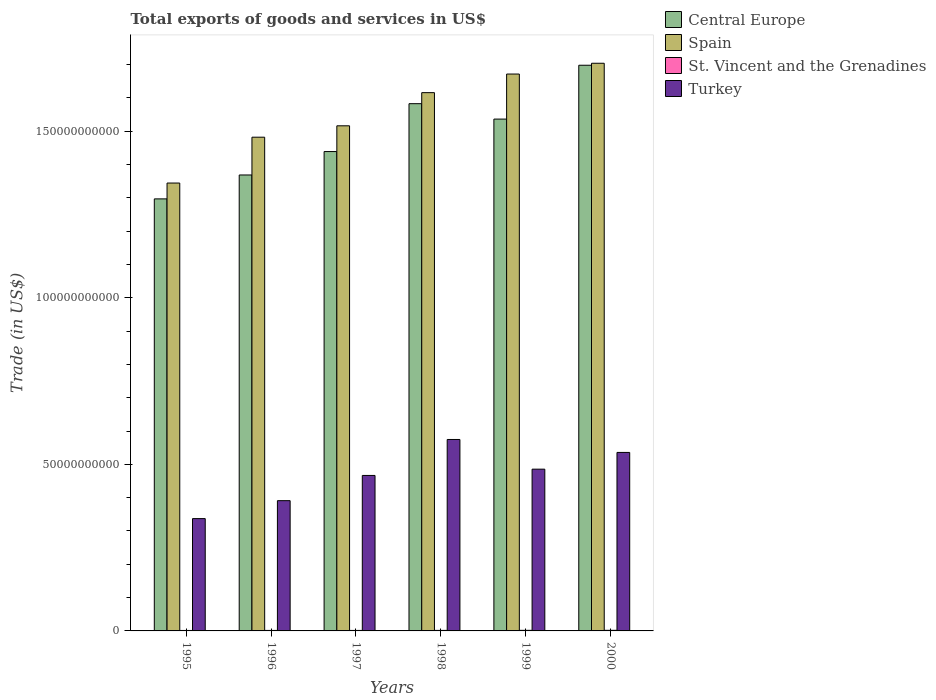How many different coloured bars are there?
Make the answer very short. 4. How many groups of bars are there?
Ensure brevity in your answer.  6. How many bars are there on the 4th tick from the right?
Keep it short and to the point. 4. What is the total exports of goods and services in Central Europe in 1998?
Your response must be concise. 1.58e+11. Across all years, what is the maximum total exports of goods and services in St. Vincent and the Grenadines?
Keep it short and to the point. 1.79e+08. Across all years, what is the minimum total exports of goods and services in St. Vincent and the Grenadines?
Your answer should be compact. 1.36e+08. What is the total total exports of goods and services in St. Vincent and the Grenadines in the graph?
Give a very brief answer. 9.48e+08. What is the difference between the total exports of goods and services in Spain in 1997 and that in 1999?
Make the answer very short. -1.55e+1. What is the difference between the total exports of goods and services in Spain in 1999 and the total exports of goods and services in Central Europe in 1996?
Your answer should be very brief. 3.03e+1. What is the average total exports of goods and services in Central Europe per year?
Make the answer very short. 1.49e+11. In the year 2000, what is the difference between the total exports of goods and services in Spain and total exports of goods and services in Turkey?
Your answer should be very brief. 1.17e+11. In how many years, is the total exports of goods and services in Turkey greater than 20000000000 US$?
Give a very brief answer. 6. What is the ratio of the total exports of goods and services in Spain in 1995 to that in 1998?
Your answer should be compact. 0.83. Is the total exports of goods and services in Central Europe in 1999 less than that in 2000?
Make the answer very short. Yes. What is the difference between the highest and the second highest total exports of goods and services in St. Vincent and the Grenadines?
Keep it short and to the point. 2.23e+06. What is the difference between the highest and the lowest total exports of goods and services in St. Vincent and the Grenadines?
Keep it short and to the point. 4.31e+07. In how many years, is the total exports of goods and services in St. Vincent and the Grenadines greater than the average total exports of goods and services in St. Vincent and the Grenadines taken over all years?
Offer a very short reply. 2. Is the sum of the total exports of goods and services in Spain in 1999 and 2000 greater than the maximum total exports of goods and services in Central Europe across all years?
Make the answer very short. Yes. Is it the case that in every year, the sum of the total exports of goods and services in Turkey and total exports of goods and services in Central Europe is greater than the sum of total exports of goods and services in Spain and total exports of goods and services in St. Vincent and the Grenadines?
Offer a very short reply. Yes. What does the 2nd bar from the left in 1999 represents?
Your response must be concise. Spain. Is it the case that in every year, the sum of the total exports of goods and services in St. Vincent and the Grenadines and total exports of goods and services in Spain is greater than the total exports of goods and services in Central Europe?
Keep it short and to the point. Yes. How many bars are there?
Provide a short and direct response. 24. Are all the bars in the graph horizontal?
Your answer should be compact. No. How many years are there in the graph?
Give a very brief answer. 6. Are the values on the major ticks of Y-axis written in scientific E-notation?
Your answer should be compact. No. How many legend labels are there?
Your response must be concise. 4. How are the legend labels stacked?
Your answer should be compact. Vertical. What is the title of the graph?
Your response must be concise. Total exports of goods and services in US$. What is the label or title of the X-axis?
Your response must be concise. Years. What is the label or title of the Y-axis?
Offer a very short reply. Trade (in US$). What is the Trade (in US$) in Central Europe in 1995?
Provide a short and direct response. 1.30e+11. What is the Trade (in US$) of Spain in 1995?
Provide a short and direct response. 1.34e+11. What is the Trade (in US$) in St. Vincent and the Grenadines in 1995?
Provide a short and direct response. 1.36e+08. What is the Trade (in US$) in Turkey in 1995?
Provide a short and direct response. 3.37e+1. What is the Trade (in US$) of Central Europe in 1996?
Your answer should be compact. 1.37e+11. What is the Trade (in US$) of Spain in 1996?
Offer a very short reply. 1.48e+11. What is the Trade (in US$) in St. Vincent and the Grenadines in 1996?
Your response must be concise. 1.49e+08. What is the Trade (in US$) of Turkey in 1996?
Give a very brief answer. 3.91e+1. What is the Trade (in US$) in Central Europe in 1997?
Your answer should be compact. 1.44e+11. What is the Trade (in US$) in Spain in 1997?
Provide a short and direct response. 1.52e+11. What is the Trade (in US$) in St. Vincent and the Grenadines in 1997?
Provide a short and direct response. 1.48e+08. What is the Trade (in US$) in Turkey in 1997?
Your response must be concise. 4.67e+1. What is the Trade (in US$) of Central Europe in 1998?
Provide a succinct answer. 1.58e+11. What is the Trade (in US$) in Spain in 1998?
Offer a terse response. 1.62e+11. What is the Trade (in US$) in St. Vincent and the Grenadines in 1998?
Keep it short and to the point. 1.57e+08. What is the Trade (in US$) of Turkey in 1998?
Your answer should be compact. 5.75e+1. What is the Trade (in US$) in Central Europe in 1999?
Keep it short and to the point. 1.54e+11. What is the Trade (in US$) of Spain in 1999?
Your response must be concise. 1.67e+11. What is the Trade (in US$) of St. Vincent and the Grenadines in 1999?
Your response must be concise. 1.77e+08. What is the Trade (in US$) in Turkey in 1999?
Provide a succinct answer. 4.86e+1. What is the Trade (in US$) in Central Europe in 2000?
Provide a succinct answer. 1.70e+11. What is the Trade (in US$) of Spain in 2000?
Make the answer very short. 1.70e+11. What is the Trade (in US$) in St. Vincent and the Grenadines in 2000?
Offer a very short reply. 1.79e+08. What is the Trade (in US$) of Turkey in 2000?
Provide a short and direct response. 5.36e+1. Across all years, what is the maximum Trade (in US$) of Central Europe?
Keep it short and to the point. 1.70e+11. Across all years, what is the maximum Trade (in US$) of Spain?
Provide a short and direct response. 1.70e+11. Across all years, what is the maximum Trade (in US$) in St. Vincent and the Grenadines?
Offer a terse response. 1.79e+08. Across all years, what is the maximum Trade (in US$) in Turkey?
Offer a very short reply. 5.75e+1. Across all years, what is the minimum Trade (in US$) in Central Europe?
Keep it short and to the point. 1.30e+11. Across all years, what is the minimum Trade (in US$) of Spain?
Provide a succinct answer. 1.34e+11. Across all years, what is the minimum Trade (in US$) of St. Vincent and the Grenadines?
Provide a short and direct response. 1.36e+08. Across all years, what is the minimum Trade (in US$) in Turkey?
Ensure brevity in your answer.  3.37e+1. What is the total Trade (in US$) in Central Europe in the graph?
Offer a terse response. 8.92e+11. What is the total Trade (in US$) in Spain in the graph?
Your answer should be very brief. 9.33e+11. What is the total Trade (in US$) in St. Vincent and the Grenadines in the graph?
Provide a short and direct response. 9.48e+08. What is the total Trade (in US$) in Turkey in the graph?
Offer a very short reply. 2.79e+11. What is the difference between the Trade (in US$) of Central Europe in 1995 and that in 1996?
Give a very brief answer. -7.17e+09. What is the difference between the Trade (in US$) of Spain in 1995 and that in 1996?
Your answer should be compact. -1.38e+1. What is the difference between the Trade (in US$) of St. Vincent and the Grenadines in 1995 and that in 1996?
Ensure brevity in your answer.  -1.29e+07. What is the difference between the Trade (in US$) in Turkey in 1995 and that in 1996?
Your answer should be very brief. -5.38e+09. What is the difference between the Trade (in US$) in Central Europe in 1995 and that in 1997?
Your answer should be very brief. -1.42e+1. What is the difference between the Trade (in US$) in Spain in 1995 and that in 1997?
Provide a short and direct response. -1.72e+1. What is the difference between the Trade (in US$) in St. Vincent and the Grenadines in 1995 and that in 1997?
Your answer should be very brief. -1.20e+07. What is the difference between the Trade (in US$) of Turkey in 1995 and that in 1997?
Offer a terse response. -1.30e+1. What is the difference between the Trade (in US$) of Central Europe in 1995 and that in 1998?
Your response must be concise. -2.86e+1. What is the difference between the Trade (in US$) in Spain in 1995 and that in 1998?
Offer a very short reply. -2.71e+1. What is the difference between the Trade (in US$) of St. Vincent and the Grenadines in 1995 and that in 1998?
Offer a very short reply. -2.11e+07. What is the difference between the Trade (in US$) of Turkey in 1995 and that in 1998?
Keep it short and to the point. -2.37e+1. What is the difference between the Trade (in US$) of Central Europe in 1995 and that in 1999?
Provide a short and direct response. -2.39e+1. What is the difference between the Trade (in US$) of Spain in 1995 and that in 1999?
Your answer should be compact. -3.27e+1. What is the difference between the Trade (in US$) in St. Vincent and the Grenadines in 1995 and that in 1999?
Make the answer very short. -4.09e+07. What is the difference between the Trade (in US$) in Turkey in 1995 and that in 1999?
Make the answer very short. -1.48e+1. What is the difference between the Trade (in US$) of Central Europe in 1995 and that in 2000?
Make the answer very short. -4.01e+1. What is the difference between the Trade (in US$) in Spain in 1995 and that in 2000?
Provide a succinct answer. -3.60e+1. What is the difference between the Trade (in US$) of St. Vincent and the Grenadines in 1995 and that in 2000?
Your response must be concise. -4.31e+07. What is the difference between the Trade (in US$) of Turkey in 1995 and that in 2000?
Your answer should be very brief. -1.99e+1. What is the difference between the Trade (in US$) in Central Europe in 1996 and that in 1997?
Keep it short and to the point. -7.03e+09. What is the difference between the Trade (in US$) in Spain in 1996 and that in 1997?
Keep it short and to the point. -3.42e+09. What is the difference between the Trade (in US$) in St. Vincent and the Grenadines in 1996 and that in 1997?
Make the answer very short. 8.93e+05. What is the difference between the Trade (in US$) of Turkey in 1996 and that in 1997?
Give a very brief answer. -7.57e+09. What is the difference between the Trade (in US$) of Central Europe in 1996 and that in 1998?
Ensure brevity in your answer.  -2.14e+1. What is the difference between the Trade (in US$) in Spain in 1996 and that in 1998?
Offer a very short reply. -1.34e+1. What is the difference between the Trade (in US$) of St. Vincent and the Grenadines in 1996 and that in 1998?
Your response must be concise. -8.18e+06. What is the difference between the Trade (in US$) in Turkey in 1996 and that in 1998?
Your answer should be compact. -1.84e+1. What is the difference between the Trade (in US$) in Central Europe in 1996 and that in 1999?
Provide a succinct answer. -1.68e+1. What is the difference between the Trade (in US$) of Spain in 1996 and that in 1999?
Give a very brief answer. -1.90e+1. What is the difference between the Trade (in US$) in St. Vincent and the Grenadines in 1996 and that in 1999?
Offer a terse response. -2.79e+07. What is the difference between the Trade (in US$) of Turkey in 1996 and that in 1999?
Keep it short and to the point. -9.46e+09. What is the difference between the Trade (in US$) of Central Europe in 1996 and that in 2000?
Offer a very short reply. -3.29e+1. What is the difference between the Trade (in US$) of Spain in 1996 and that in 2000?
Offer a very short reply. -2.22e+1. What is the difference between the Trade (in US$) of St. Vincent and the Grenadines in 1996 and that in 2000?
Keep it short and to the point. -3.02e+07. What is the difference between the Trade (in US$) of Turkey in 1996 and that in 2000?
Make the answer very short. -1.45e+1. What is the difference between the Trade (in US$) of Central Europe in 1997 and that in 1998?
Your response must be concise. -1.44e+1. What is the difference between the Trade (in US$) in Spain in 1997 and that in 1998?
Your answer should be very brief. -9.95e+09. What is the difference between the Trade (in US$) in St. Vincent and the Grenadines in 1997 and that in 1998?
Provide a succinct answer. -9.07e+06. What is the difference between the Trade (in US$) in Turkey in 1997 and that in 1998?
Ensure brevity in your answer.  -1.08e+1. What is the difference between the Trade (in US$) in Central Europe in 1997 and that in 1999?
Your answer should be very brief. -9.75e+09. What is the difference between the Trade (in US$) in Spain in 1997 and that in 1999?
Make the answer very short. -1.55e+1. What is the difference between the Trade (in US$) in St. Vincent and the Grenadines in 1997 and that in 1999?
Offer a very short reply. -2.88e+07. What is the difference between the Trade (in US$) in Turkey in 1997 and that in 1999?
Provide a short and direct response. -1.89e+09. What is the difference between the Trade (in US$) of Central Europe in 1997 and that in 2000?
Give a very brief answer. -2.59e+1. What is the difference between the Trade (in US$) in Spain in 1997 and that in 2000?
Offer a very short reply. -1.88e+1. What is the difference between the Trade (in US$) in St. Vincent and the Grenadines in 1997 and that in 2000?
Your response must be concise. -3.11e+07. What is the difference between the Trade (in US$) in Turkey in 1997 and that in 2000?
Offer a terse response. -6.91e+09. What is the difference between the Trade (in US$) in Central Europe in 1998 and that in 1999?
Give a very brief answer. 4.62e+09. What is the difference between the Trade (in US$) of Spain in 1998 and that in 1999?
Provide a short and direct response. -5.58e+09. What is the difference between the Trade (in US$) of St. Vincent and the Grenadines in 1998 and that in 1999?
Ensure brevity in your answer.  -1.98e+07. What is the difference between the Trade (in US$) in Turkey in 1998 and that in 1999?
Your answer should be compact. 8.91e+09. What is the difference between the Trade (in US$) of Central Europe in 1998 and that in 2000?
Your answer should be compact. -1.15e+1. What is the difference between the Trade (in US$) of Spain in 1998 and that in 2000?
Provide a succinct answer. -8.82e+09. What is the difference between the Trade (in US$) in St. Vincent and the Grenadines in 1998 and that in 2000?
Your answer should be compact. -2.20e+07. What is the difference between the Trade (in US$) in Turkey in 1998 and that in 2000?
Offer a terse response. 3.89e+09. What is the difference between the Trade (in US$) in Central Europe in 1999 and that in 2000?
Your response must be concise. -1.62e+1. What is the difference between the Trade (in US$) of Spain in 1999 and that in 2000?
Your response must be concise. -3.24e+09. What is the difference between the Trade (in US$) in St. Vincent and the Grenadines in 1999 and that in 2000?
Your response must be concise. -2.23e+06. What is the difference between the Trade (in US$) in Turkey in 1999 and that in 2000?
Provide a succinct answer. -5.02e+09. What is the difference between the Trade (in US$) in Central Europe in 1995 and the Trade (in US$) in Spain in 1996?
Give a very brief answer. -1.85e+1. What is the difference between the Trade (in US$) of Central Europe in 1995 and the Trade (in US$) of St. Vincent and the Grenadines in 1996?
Your answer should be very brief. 1.30e+11. What is the difference between the Trade (in US$) in Central Europe in 1995 and the Trade (in US$) in Turkey in 1996?
Offer a terse response. 9.06e+1. What is the difference between the Trade (in US$) in Spain in 1995 and the Trade (in US$) in St. Vincent and the Grenadines in 1996?
Offer a very short reply. 1.34e+11. What is the difference between the Trade (in US$) of Spain in 1995 and the Trade (in US$) of Turkey in 1996?
Provide a short and direct response. 9.53e+1. What is the difference between the Trade (in US$) of St. Vincent and the Grenadines in 1995 and the Trade (in US$) of Turkey in 1996?
Provide a succinct answer. -3.90e+1. What is the difference between the Trade (in US$) of Central Europe in 1995 and the Trade (in US$) of Spain in 1997?
Provide a succinct answer. -2.19e+1. What is the difference between the Trade (in US$) of Central Europe in 1995 and the Trade (in US$) of St. Vincent and the Grenadines in 1997?
Give a very brief answer. 1.30e+11. What is the difference between the Trade (in US$) of Central Europe in 1995 and the Trade (in US$) of Turkey in 1997?
Provide a succinct answer. 8.30e+1. What is the difference between the Trade (in US$) in Spain in 1995 and the Trade (in US$) in St. Vincent and the Grenadines in 1997?
Ensure brevity in your answer.  1.34e+11. What is the difference between the Trade (in US$) in Spain in 1995 and the Trade (in US$) in Turkey in 1997?
Make the answer very short. 8.78e+1. What is the difference between the Trade (in US$) of St. Vincent and the Grenadines in 1995 and the Trade (in US$) of Turkey in 1997?
Keep it short and to the point. -4.65e+1. What is the difference between the Trade (in US$) of Central Europe in 1995 and the Trade (in US$) of Spain in 1998?
Make the answer very short. -3.19e+1. What is the difference between the Trade (in US$) of Central Europe in 1995 and the Trade (in US$) of St. Vincent and the Grenadines in 1998?
Give a very brief answer. 1.30e+11. What is the difference between the Trade (in US$) of Central Europe in 1995 and the Trade (in US$) of Turkey in 1998?
Your answer should be compact. 7.22e+1. What is the difference between the Trade (in US$) in Spain in 1995 and the Trade (in US$) in St. Vincent and the Grenadines in 1998?
Provide a short and direct response. 1.34e+11. What is the difference between the Trade (in US$) of Spain in 1995 and the Trade (in US$) of Turkey in 1998?
Provide a succinct answer. 7.70e+1. What is the difference between the Trade (in US$) of St. Vincent and the Grenadines in 1995 and the Trade (in US$) of Turkey in 1998?
Provide a short and direct response. -5.73e+1. What is the difference between the Trade (in US$) in Central Europe in 1995 and the Trade (in US$) in Spain in 1999?
Your answer should be very brief. -3.75e+1. What is the difference between the Trade (in US$) in Central Europe in 1995 and the Trade (in US$) in St. Vincent and the Grenadines in 1999?
Keep it short and to the point. 1.29e+11. What is the difference between the Trade (in US$) in Central Europe in 1995 and the Trade (in US$) in Turkey in 1999?
Your answer should be very brief. 8.11e+1. What is the difference between the Trade (in US$) in Spain in 1995 and the Trade (in US$) in St. Vincent and the Grenadines in 1999?
Give a very brief answer. 1.34e+11. What is the difference between the Trade (in US$) in Spain in 1995 and the Trade (in US$) in Turkey in 1999?
Make the answer very short. 8.59e+1. What is the difference between the Trade (in US$) in St. Vincent and the Grenadines in 1995 and the Trade (in US$) in Turkey in 1999?
Offer a very short reply. -4.84e+1. What is the difference between the Trade (in US$) of Central Europe in 1995 and the Trade (in US$) of Spain in 2000?
Keep it short and to the point. -4.07e+1. What is the difference between the Trade (in US$) of Central Europe in 1995 and the Trade (in US$) of St. Vincent and the Grenadines in 2000?
Your answer should be compact. 1.29e+11. What is the difference between the Trade (in US$) in Central Europe in 1995 and the Trade (in US$) in Turkey in 2000?
Give a very brief answer. 7.61e+1. What is the difference between the Trade (in US$) in Spain in 1995 and the Trade (in US$) in St. Vincent and the Grenadines in 2000?
Your response must be concise. 1.34e+11. What is the difference between the Trade (in US$) of Spain in 1995 and the Trade (in US$) of Turkey in 2000?
Your answer should be very brief. 8.09e+1. What is the difference between the Trade (in US$) of St. Vincent and the Grenadines in 1995 and the Trade (in US$) of Turkey in 2000?
Offer a very short reply. -5.34e+1. What is the difference between the Trade (in US$) in Central Europe in 1996 and the Trade (in US$) in Spain in 1997?
Keep it short and to the point. -1.48e+1. What is the difference between the Trade (in US$) of Central Europe in 1996 and the Trade (in US$) of St. Vincent and the Grenadines in 1997?
Keep it short and to the point. 1.37e+11. What is the difference between the Trade (in US$) in Central Europe in 1996 and the Trade (in US$) in Turkey in 1997?
Ensure brevity in your answer.  9.02e+1. What is the difference between the Trade (in US$) of Spain in 1996 and the Trade (in US$) of St. Vincent and the Grenadines in 1997?
Provide a succinct answer. 1.48e+11. What is the difference between the Trade (in US$) of Spain in 1996 and the Trade (in US$) of Turkey in 1997?
Keep it short and to the point. 1.02e+11. What is the difference between the Trade (in US$) of St. Vincent and the Grenadines in 1996 and the Trade (in US$) of Turkey in 1997?
Keep it short and to the point. -4.65e+1. What is the difference between the Trade (in US$) in Central Europe in 1996 and the Trade (in US$) in Spain in 1998?
Keep it short and to the point. -2.47e+1. What is the difference between the Trade (in US$) in Central Europe in 1996 and the Trade (in US$) in St. Vincent and the Grenadines in 1998?
Ensure brevity in your answer.  1.37e+11. What is the difference between the Trade (in US$) of Central Europe in 1996 and the Trade (in US$) of Turkey in 1998?
Give a very brief answer. 7.94e+1. What is the difference between the Trade (in US$) in Spain in 1996 and the Trade (in US$) in St. Vincent and the Grenadines in 1998?
Your answer should be compact. 1.48e+11. What is the difference between the Trade (in US$) of Spain in 1996 and the Trade (in US$) of Turkey in 1998?
Provide a short and direct response. 9.07e+1. What is the difference between the Trade (in US$) in St. Vincent and the Grenadines in 1996 and the Trade (in US$) in Turkey in 1998?
Give a very brief answer. -5.73e+1. What is the difference between the Trade (in US$) in Central Europe in 1996 and the Trade (in US$) in Spain in 1999?
Your answer should be compact. -3.03e+1. What is the difference between the Trade (in US$) in Central Europe in 1996 and the Trade (in US$) in St. Vincent and the Grenadines in 1999?
Keep it short and to the point. 1.37e+11. What is the difference between the Trade (in US$) of Central Europe in 1996 and the Trade (in US$) of Turkey in 1999?
Keep it short and to the point. 8.83e+1. What is the difference between the Trade (in US$) of Spain in 1996 and the Trade (in US$) of St. Vincent and the Grenadines in 1999?
Your answer should be compact. 1.48e+11. What is the difference between the Trade (in US$) in Spain in 1996 and the Trade (in US$) in Turkey in 1999?
Keep it short and to the point. 9.96e+1. What is the difference between the Trade (in US$) of St. Vincent and the Grenadines in 1996 and the Trade (in US$) of Turkey in 1999?
Your response must be concise. -4.84e+1. What is the difference between the Trade (in US$) of Central Europe in 1996 and the Trade (in US$) of Spain in 2000?
Your answer should be compact. -3.35e+1. What is the difference between the Trade (in US$) in Central Europe in 1996 and the Trade (in US$) in St. Vincent and the Grenadines in 2000?
Make the answer very short. 1.37e+11. What is the difference between the Trade (in US$) of Central Europe in 1996 and the Trade (in US$) of Turkey in 2000?
Provide a succinct answer. 8.33e+1. What is the difference between the Trade (in US$) in Spain in 1996 and the Trade (in US$) in St. Vincent and the Grenadines in 2000?
Make the answer very short. 1.48e+11. What is the difference between the Trade (in US$) in Spain in 1996 and the Trade (in US$) in Turkey in 2000?
Offer a terse response. 9.46e+1. What is the difference between the Trade (in US$) in St. Vincent and the Grenadines in 1996 and the Trade (in US$) in Turkey in 2000?
Your response must be concise. -5.34e+1. What is the difference between the Trade (in US$) of Central Europe in 1997 and the Trade (in US$) of Spain in 1998?
Offer a terse response. -1.77e+1. What is the difference between the Trade (in US$) of Central Europe in 1997 and the Trade (in US$) of St. Vincent and the Grenadines in 1998?
Provide a short and direct response. 1.44e+11. What is the difference between the Trade (in US$) in Central Europe in 1997 and the Trade (in US$) in Turkey in 1998?
Provide a succinct answer. 8.64e+1. What is the difference between the Trade (in US$) in Spain in 1997 and the Trade (in US$) in St. Vincent and the Grenadines in 1998?
Offer a terse response. 1.51e+11. What is the difference between the Trade (in US$) in Spain in 1997 and the Trade (in US$) in Turkey in 1998?
Keep it short and to the point. 9.42e+1. What is the difference between the Trade (in US$) in St. Vincent and the Grenadines in 1997 and the Trade (in US$) in Turkey in 1998?
Provide a succinct answer. -5.73e+1. What is the difference between the Trade (in US$) in Central Europe in 1997 and the Trade (in US$) in Spain in 1999?
Offer a very short reply. -2.33e+1. What is the difference between the Trade (in US$) of Central Europe in 1997 and the Trade (in US$) of St. Vincent and the Grenadines in 1999?
Keep it short and to the point. 1.44e+11. What is the difference between the Trade (in US$) in Central Europe in 1997 and the Trade (in US$) in Turkey in 1999?
Give a very brief answer. 9.53e+1. What is the difference between the Trade (in US$) in Spain in 1997 and the Trade (in US$) in St. Vincent and the Grenadines in 1999?
Provide a short and direct response. 1.51e+11. What is the difference between the Trade (in US$) of Spain in 1997 and the Trade (in US$) of Turkey in 1999?
Ensure brevity in your answer.  1.03e+11. What is the difference between the Trade (in US$) of St. Vincent and the Grenadines in 1997 and the Trade (in US$) of Turkey in 1999?
Your response must be concise. -4.84e+1. What is the difference between the Trade (in US$) of Central Europe in 1997 and the Trade (in US$) of Spain in 2000?
Your answer should be compact. -2.65e+1. What is the difference between the Trade (in US$) in Central Europe in 1997 and the Trade (in US$) in St. Vincent and the Grenadines in 2000?
Provide a succinct answer. 1.44e+11. What is the difference between the Trade (in US$) in Central Europe in 1997 and the Trade (in US$) in Turkey in 2000?
Ensure brevity in your answer.  9.03e+1. What is the difference between the Trade (in US$) of Spain in 1997 and the Trade (in US$) of St. Vincent and the Grenadines in 2000?
Provide a short and direct response. 1.51e+11. What is the difference between the Trade (in US$) of Spain in 1997 and the Trade (in US$) of Turkey in 2000?
Your answer should be very brief. 9.80e+1. What is the difference between the Trade (in US$) of St. Vincent and the Grenadines in 1997 and the Trade (in US$) of Turkey in 2000?
Offer a terse response. -5.34e+1. What is the difference between the Trade (in US$) in Central Europe in 1998 and the Trade (in US$) in Spain in 1999?
Offer a terse response. -8.90e+09. What is the difference between the Trade (in US$) in Central Europe in 1998 and the Trade (in US$) in St. Vincent and the Grenadines in 1999?
Make the answer very short. 1.58e+11. What is the difference between the Trade (in US$) in Central Europe in 1998 and the Trade (in US$) in Turkey in 1999?
Provide a succinct answer. 1.10e+11. What is the difference between the Trade (in US$) in Spain in 1998 and the Trade (in US$) in St. Vincent and the Grenadines in 1999?
Make the answer very short. 1.61e+11. What is the difference between the Trade (in US$) in Spain in 1998 and the Trade (in US$) in Turkey in 1999?
Your response must be concise. 1.13e+11. What is the difference between the Trade (in US$) of St. Vincent and the Grenadines in 1998 and the Trade (in US$) of Turkey in 1999?
Your answer should be compact. -4.84e+1. What is the difference between the Trade (in US$) of Central Europe in 1998 and the Trade (in US$) of Spain in 2000?
Make the answer very short. -1.21e+1. What is the difference between the Trade (in US$) of Central Europe in 1998 and the Trade (in US$) of St. Vincent and the Grenadines in 2000?
Make the answer very short. 1.58e+11. What is the difference between the Trade (in US$) of Central Europe in 1998 and the Trade (in US$) of Turkey in 2000?
Your answer should be compact. 1.05e+11. What is the difference between the Trade (in US$) in Spain in 1998 and the Trade (in US$) in St. Vincent and the Grenadines in 2000?
Offer a very short reply. 1.61e+11. What is the difference between the Trade (in US$) in Spain in 1998 and the Trade (in US$) in Turkey in 2000?
Provide a succinct answer. 1.08e+11. What is the difference between the Trade (in US$) in St. Vincent and the Grenadines in 1998 and the Trade (in US$) in Turkey in 2000?
Keep it short and to the point. -5.34e+1. What is the difference between the Trade (in US$) in Central Europe in 1999 and the Trade (in US$) in Spain in 2000?
Make the answer very short. -1.68e+1. What is the difference between the Trade (in US$) in Central Europe in 1999 and the Trade (in US$) in St. Vincent and the Grenadines in 2000?
Make the answer very short. 1.53e+11. What is the difference between the Trade (in US$) of Central Europe in 1999 and the Trade (in US$) of Turkey in 2000?
Ensure brevity in your answer.  1.00e+11. What is the difference between the Trade (in US$) of Spain in 1999 and the Trade (in US$) of St. Vincent and the Grenadines in 2000?
Provide a short and direct response. 1.67e+11. What is the difference between the Trade (in US$) in Spain in 1999 and the Trade (in US$) in Turkey in 2000?
Make the answer very short. 1.14e+11. What is the difference between the Trade (in US$) of St. Vincent and the Grenadines in 1999 and the Trade (in US$) of Turkey in 2000?
Your answer should be very brief. -5.34e+1. What is the average Trade (in US$) in Central Europe per year?
Make the answer very short. 1.49e+11. What is the average Trade (in US$) of Spain per year?
Your response must be concise. 1.56e+11. What is the average Trade (in US$) of St. Vincent and the Grenadines per year?
Offer a terse response. 1.58e+08. What is the average Trade (in US$) of Turkey per year?
Ensure brevity in your answer.  4.65e+1. In the year 1995, what is the difference between the Trade (in US$) in Central Europe and Trade (in US$) in Spain?
Keep it short and to the point. -4.75e+09. In the year 1995, what is the difference between the Trade (in US$) in Central Europe and Trade (in US$) in St. Vincent and the Grenadines?
Ensure brevity in your answer.  1.30e+11. In the year 1995, what is the difference between the Trade (in US$) in Central Europe and Trade (in US$) in Turkey?
Your response must be concise. 9.60e+1. In the year 1995, what is the difference between the Trade (in US$) of Spain and Trade (in US$) of St. Vincent and the Grenadines?
Your response must be concise. 1.34e+11. In the year 1995, what is the difference between the Trade (in US$) of Spain and Trade (in US$) of Turkey?
Your answer should be very brief. 1.01e+11. In the year 1995, what is the difference between the Trade (in US$) in St. Vincent and the Grenadines and Trade (in US$) in Turkey?
Offer a terse response. -3.36e+1. In the year 1996, what is the difference between the Trade (in US$) of Central Europe and Trade (in US$) of Spain?
Your answer should be compact. -1.13e+1. In the year 1996, what is the difference between the Trade (in US$) in Central Europe and Trade (in US$) in St. Vincent and the Grenadines?
Your response must be concise. 1.37e+11. In the year 1996, what is the difference between the Trade (in US$) in Central Europe and Trade (in US$) in Turkey?
Offer a very short reply. 9.78e+1. In the year 1996, what is the difference between the Trade (in US$) in Spain and Trade (in US$) in St. Vincent and the Grenadines?
Make the answer very short. 1.48e+11. In the year 1996, what is the difference between the Trade (in US$) in Spain and Trade (in US$) in Turkey?
Offer a terse response. 1.09e+11. In the year 1996, what is the difference between the Trade (in US$) in St. Vincent and the Grenadines and Trade (in US$) in Turkey?
Your answer should be very brief. -3.89e+1. In the year 1997, what is the difference between the Trade (in US$) of Central Europe and Trade (in US$) of Spain?
Your response must be concise. -7.73e+09. In the year 1997, what is the difference between the Trade (in US$) of Central Europe and Trade (in US$) of St. Vincent and the Grenadines?
Provide a short and direct response. 1.44e+11. In the year 1997, what is the difference between the Trade (in US$) in Central Europe and Trade (in US$) in Turkey?
Your response must be concise. 9.72e+1. In the year 1997, what is the difference between the Trade (in US$) in Spain and Trade (in US$) in St. Vincent and the Grenadines?
Your answer should be compact. 1.51e+11. In the year 1997, what is the difference between the Trade (in US$) in Spain and Trade (in US$) in Turkey?
Your answer should be very brief. 1.05e+11. In the year 1997, what is the difference between the Trade (in US$) in St. Vincent and the Grenadines and Trade (in US$) in Turkey?
Provide a succinct answer. -4.65e+1. In the year 1998, what is the difference between the Trade (in US$) of Central Europe and Trade (in US$) of Spain?
Give a very brief answer. -3.31e+09. In the year 1998, what is the difference between the Trade (in US$) of Central Europe and Trade (in US$) of St. Vincent and the Grenadines?
Ensure brevity in your answer.  1.58e+11. In the year 1998, what is the difference between the Trade (in US$) of Central Europe and Trade (in US$) of Turkey?
Your answer should be compact. 1.01e+11. In the year 1998, what is the difference between the Trade (in US$) of Spain and Trade (in US$) of St. Vincent and the Grenadines?
Offer a very short reply. 1.61e+11. In the year 1998, what is the difference between the Trade (in US$) in Spain and Trade (in US$) in Turkey?
Your answer should be compact. 1.04e+11. In the year 1998, what is the difference between the Trade (in US$) of St. Vincent and the Grenadines and Trade (in US$) of Turkey?
Give a very brief answer. -5.73e+1. In the year 1999, what is the difference between the Trade (in US$) of Central Europe and Trade (in US$) of Spain?
Your answer should be very brief. -1.35e+1. In the year 1999, what is the difference between the Trade (in US$) in Central Europe and Trade (in US$) in St. Vincent and the Grenadines?
Keep it short and to the point. 1.53e+11. In the year 1999, what is the difference between the Trade (in US$) of Central Europe and Trade (in US$) of Turkey?
Ensure brevity in your answer.  1.05e+11. In the year 1999, what is the difference between the Trade (in US$) of Spain and Trade (in US$) of St. Vincent and the Grenadines?
Offer a very short reply. 1.67e+11. In the year 1999, what is the difference between the Trade (in US$) in Spain and Trade (in US$) in Turkey?
Keep it short and to the point. 1.19e+11. In the year 1999, what is the difference between the Trade (in US$) of St. Vincent and the Grenadines and Trade (in US$) of Turkey?
Your answer should be very brief. -4.84e+1. In the year 2000, what is the difference between the Trade (in US$) of Central Europe and Trade (in US$) of Spain?
Provide a short and direct response. -5.94e+08. In the year 2000, what is the difference between the Trade (in US$) of Central Europe and Trade (in US$) of St. Vincent and the Grenadines?
Provide a short and direct response. 1.70e+11. In the year 2000, what is the difference between the Trade (in US$) in Central Europe and Trade (in US$) in Turkey?
Ensure brevity in your answer.  1.16e+11. In the year 2000, what is the difference between the Trade (in US$) in Spain and Trade (in US$) in St. Vincent and the Grenadines?
Make the answer very short. 1.70e+11. In the year 2000, what is the difference between the Trade (in US$) in Spain and Trade (in US$) in Turkey?
Your answer should be very brief. 1.17e+11. In the year 2000, what is the difference between the Trade (in US$) of St. Vincent and the Grenadines and Trade (in US$) of Turkey?
Your answer should be very brief. -5.34e+1. What is the ratio of the Trade (in US$) in Central Europe in 1995 to that in 1996?
Provide a succinct answer. 0.95. What is the ratio of the Trade (in US$) in Spain in 1995 to that in 1996?
Keep it short and to the point. 0.91. What is the ratio of the Trade (in US$) in St. Vincent and the Grenadines in 1995 to that in 1996?
Provide a short and direct response. 0.91. What is the ratio of the Trade (in US$) in Turkey in 1995 to that in 1996?
Your answer should be compact. 0.86. What is the ratio of the Trade (in US$) of Central Europe in 1995 to that in 1997?
Make the answer very short. 0.9. What is the ratio of the Trade (in US$) of Spain in 1995 to that in 1997?
Provide a short and direct response. 0.89. What is the ratio of the Trade (in US$) of St. Vincent and the Grenadines in 1995 to that in 1997?
Provide a succinct answer. 0.92. What is the ratio of the Trade (in US$) of Turkey in 1995 to that in 1997?
Provide a short and direct response. 0.72. What is the ratio of the Trade (in US$) in Central Europe in 1995 to that in 1998?
Your answer should be very brief. 0.82. What is the ratio of the Trade (in US$) in Spain in 1995 to that in 1998?
Ensure brevity in your answer.  0.83. What is the ratio of the Trade (in US$) in St. Vincent and the Grenadines in 1995 to that in 1998?
Your answer should be compact. 0.87. What is the ratio of the Trade (in US$) in Turkey in 1995 to that in 1998?
Make the answer very short. 0.59. What is the ratio of the Trade (in US$) in Central Europe in 1995 to that in 1999?
Your answer should be compact. 0.84. What is the ratio of the Trade (in US$) of Spain in 1995 to that in 1999?
Your answer should be very brief. 0.8. What is the ratio of the Trade (in US$) of St. Vincent and the Grenadines in 1995 to that in 1999?
Your answer should be compact. 0.77. What is the ratio of the Trade (in US$) in Turkey in 1995 to that in 1999?
Provide a succinct answer. 0.69. What is the ratio of the Trade (in US$) in Central Europe in 1995 to that in 2000?
Provide a short and direct response. 0.76. What is the ratio of the Trade (in US$) of Spain in 1995 to that in 2000?
Make the answer very short. 0.79. What is the ratio of the Trade (in US$) of St. Vincent and the Grenadines in 1995 to that in 2000?
Your answer should be very brief. 0.76. What is the ratio of the Trade (in US$) of Turkey in 1995 to that in 2000?
Provide a succinct answer. 0.63. What is the ratio of the Trade (in US$) in Central Europe in 1996 to that in 1997?
Ensure brevity in your answer.  0.95. What is the ratio of the Trade (in US$) in Spain in 1996 to that in 1997?
Provide a succinct answer. 0.98. What is the ratio of the Trade (in US$) of St. Vincent and the Grenadines in 1996 to that in 1997?
Give a very brief answer. 1.01. What is the ratio of the Trade (in US$) of Turkey in 1996 to that in 1997?
Ensure brevity in your answer.  0.84. What is the ratio of the Trade (in US$) in Central Europe in 1996 to that in 1998?
Your answer should be compact. 0.86. What is the ratio of the Trade (in US$) in Spain in 1996 to that in 1998?
Give a very brief answer. 0.92. What is the ratio of the Trade (in US$) of St. Vincent and the Grenadines in 1996 to that in 1998?
Provide a succinct answer. 0.95. What is the ratio of the Trade (in US$) of Turkey in 1996 to that in 1998?
Your answer should be compact. 0.68. What is the ratio of the Trade (in US$) of Central Europe in 1996 to that in 1999?
Offer a terse response. 0.89. What is the ratio of the Trade (in US$) of Spain in 1996 to that in 1999?
Your answer should be very brief. 0.89. What is the ratio of the Trade (in US$) of St. Vincent and the Grenadines in 1996 to that in 1999?
Provide a succinct answer. 0.84. What is the ratio of the Trade (in US$) of Turkey in 1996 to that in 1999?
Give a very brief answer. 0.81. What is the ratio of the Trade (in US$) in Central Europe in 1996 to that in 2000?
Keep it short and to the point. 0.81. What is the ratio of the Trade (in US$) of Spain in 1996 to that in 2000?
Offer a terse response. 0.87. What is the ratio of the Trade (in US$) in St. Vincent and the Grenadines in 1996 to that in 2000?
Provide a succinct answer. 0.83. What is the ratio of the Trade (in US$) of Turkey in 1996 to that in 2000?
Provide a short and direct response. 0.73. What is the ratio of the Trade (in US$) in Central Europe in 1997 to that in 1998?
Keep it short and to the point. 0.91. What is the ratio of the Trade (in US$) of Spain in 1997 to that in 1998?
Give a very brief answer. 0.94. What is the ratio of the Trade (in US$) in St. Vincent and the Grenadines in 1997 to that in 1998?
Make the answer very short. 0.94. What is the ratio of the Trade (in US$) in Turkey in 1997 to that in 1998?
Offer a terse response. 0.81. What is the ratio of the Trade (in US$) of Central Europe in 1997 to that in 1999?
Your answer should be compact. 0.94. What is the ratio of the Trade (in US$) in Spain in 1997 to that in 1999?
Ensure brevity in your answer.  0.91. What is the ratio of the Trade (in US$) of St. Vincent and the Grenadines in 1997 to that in 1999?
Provide a succinct answer. 0.84. What is the ratio of the Trade (in US$) in Turkey in 1997 to that in 1999?
Your answer should be compact. 0.96. What is the ratio of the Trade (in US$) in Central Europe in 1997 to that in 2000?
Make the answer very short. 0.85. What is the ratio of the Trade (in US$) of Spain in 1997 to that in 2000?
Offer a terse response. 0.89. What is the ratio of the Trade (in US$) of St. Vincent and the Grenadines in 1997 to that in 2000?
Provide a short and direct response. 0.83. What is the ratio of the Trade (in US$) of Turkey in 1997 to that in 2000?
Offer a very short reply. 0.87. What is the ratio of the Trade (in US$) of Central Europe in 1998 to that in 1999?
Offer a terse response. 1.03. What is the ratio of the Trade (in US$) of Spain in 1998 to that in 1999?
Provide a succinct answer. 0.97. What is the ratio of the Trade (in US$) of St. Vincent and the Grenadines in 1998 to that in 1999?
Give a very brief answer. 0.89. What is the ratio of the Trade (in US$) in Turkey in 1998 to that in 1999?
Your response must be concise. 1.18. What is the ratio of the Trade (in US$) in Central Europe in 1998 to that in 2000?
Your answer should be very brief. 0.93. What is the ratio of the Trade (in US$) of Spain in 1998 to that in 2000?
Keep it short and to the point. 0.95. What is the ratio of the Trade (in US$) in St. Vincent and the Grenadines in 1998 to that in 2000?
Give a very brief answer. 0.88. What is the ratio of the Trade (in US$) in Turkey in 1998 to that in 2000?
Provide a short and direct response. 1.07. What is the ratio of the Trade (in US$) in Central Europe in 1999 to that in 2000?
Keep it short and to the point. 0.9. What is the ratio of the Trade (in US$) in Spain in 1999 to that in 2000?
Provide a succinct answer. 0.98. What is the ratio of the Trade (in US$) of St. Vincent and the Grenadines in 1999 to that in 2000?
Your answer should be compact. 0.99. What is the ratio of the Trade (in US$) of Turkey in 1999 to that in 2000?
Offer a terse response. 0.91. What is the difference between the highest and the second highest Trade (in US$) in Central Europe?
Ensure brevity in your answer.  1.15e+1. What is the difference between the highest and the second highest Trade (in US$) in Spain?
Provide a succinct answer. 3.24e+09. What is the difference between the highest and the second highest Trade (in US$) in St. Vincent and the Grenadines?
Give a very brief answer. 2.23e+06. What is the difference between the highest and the second highest Trade (in US$) of Turkey?
Your answer should be compact. 3.89e+09. What is the difference between the highest and the lowest Trade (in US$) in Central Europe?
Keep it short and to the point. 4.01e+1. What is the difference between the highest and the lowest Trade (in US$) in Spain?
Offer a very short reply. 3.60e+1. What is the difference between the highest and the lowest Trade (in US$) of St. Vincent and the Grenadines?
Your response must be concise. 4.31e+07. What is the difference between the highest and the lowest Trade (in US$) in Turkey?
Your answer should be very brief. 2.37e+1. 